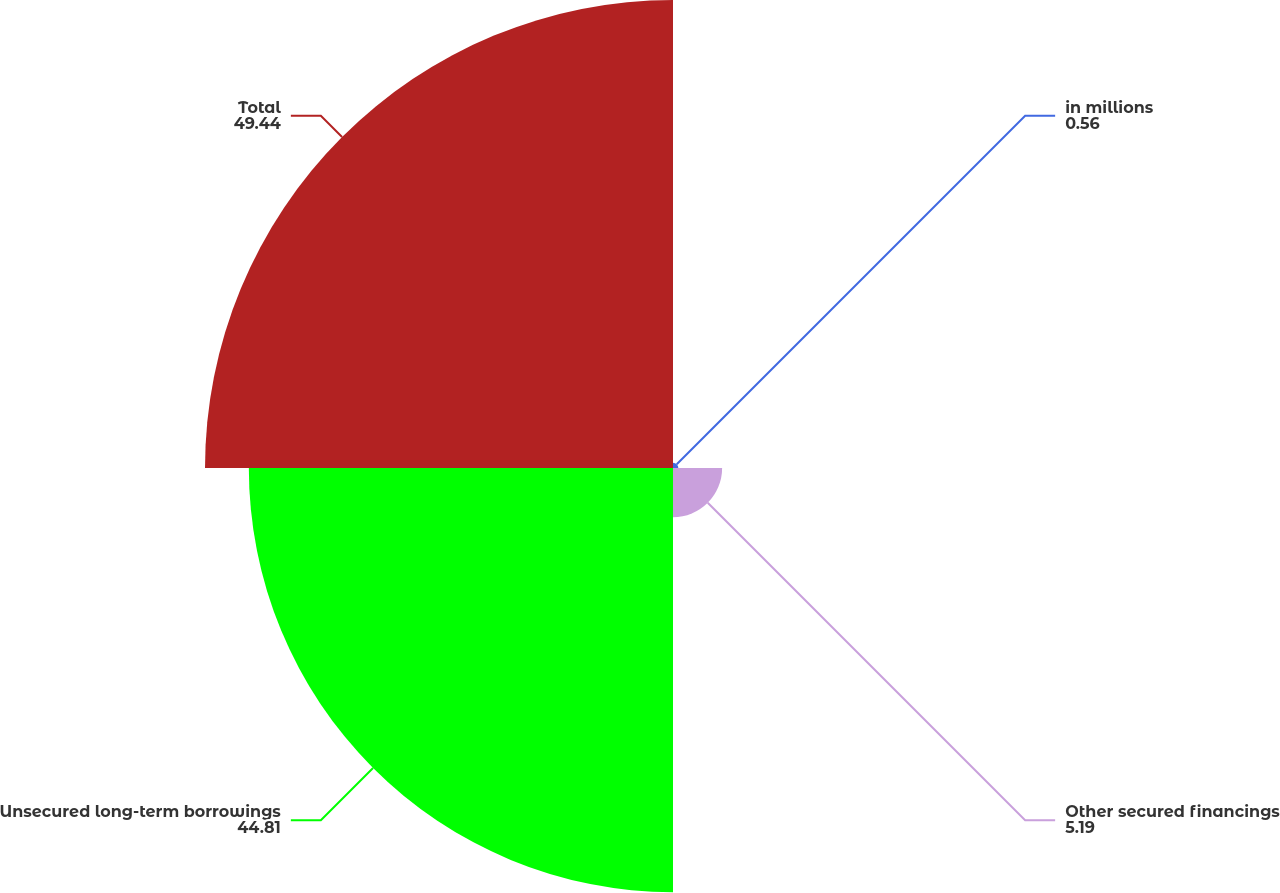<chart> <loc_0><loc_0><loc_500><loc_500><pie_chart><fcel>in millions<fcel>Other secured financings<fcel>Unsecured long-term borrowings<fcel>Total<nl><fcel>0.56%<fcel>5.19%<fcel>44.81%<fcel>49.44%<nl></chart> 